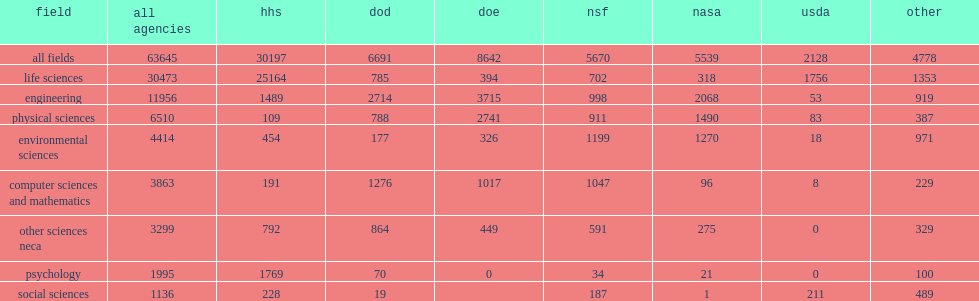How many million dollars was most of funding slated to support research in engineering? 3715.0. How many million dollars was most of funding slated to support research in physical sciences? 2741.0. How many percent did dod report of its fy 2015 research funding supported engineering? 0.405619. How many million dollars did dod report of its fy 2015 research funding supported engineering? 2714.0. How many percent did dod report supported computer sciences and mathematics? 0.190704. How many million dollars did dod report supported computer sciences and mathematics? 1276.0. 